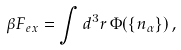Convert formula to latex. <formula><loc_0><loc_0><loc_500><loc_500>\beta F _ { e x } = \int d ^ { 3 } r \, \Phi ( \{ n _ { \alpha } \} ) \, ,</formula> 